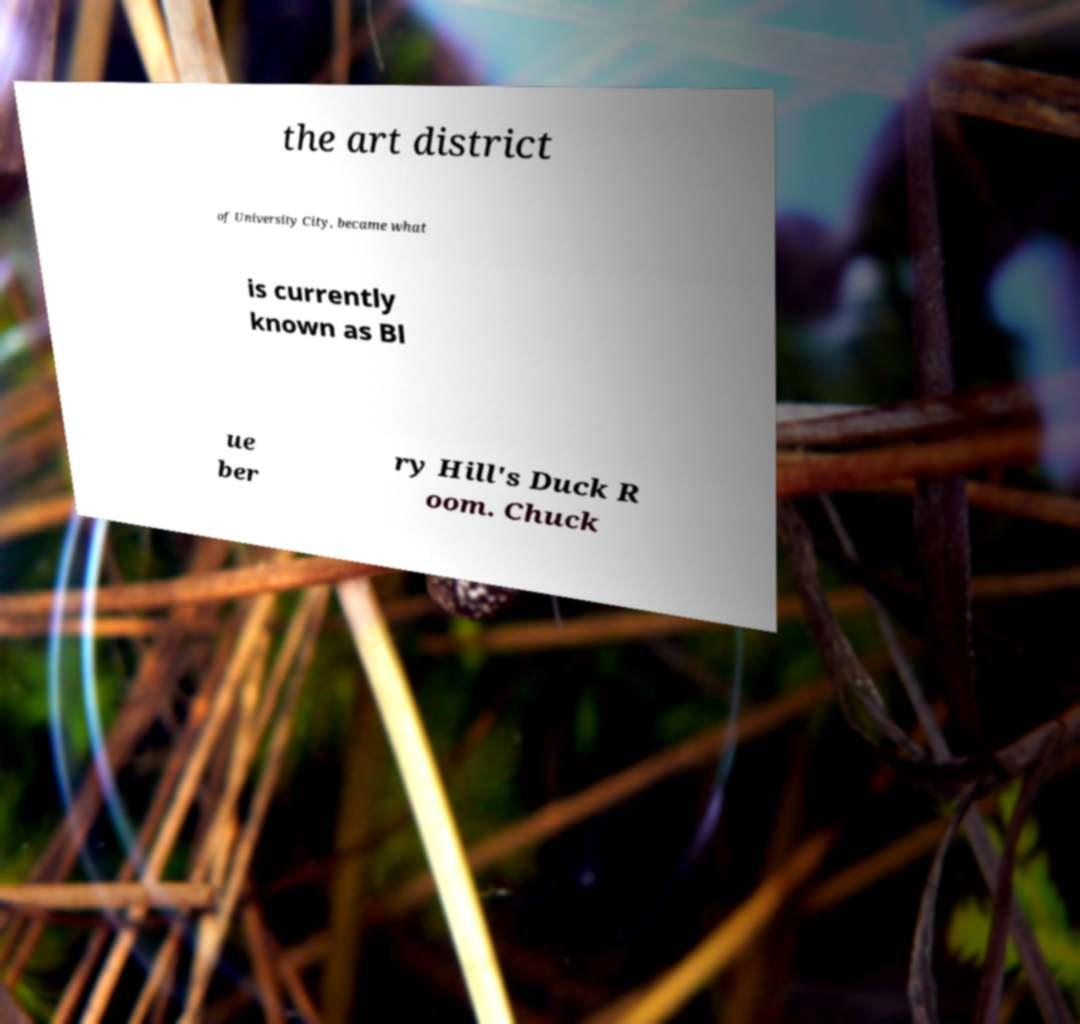Could you assist in decoding the text presented in this image and type it out clearly? the art district of University City, became what is currently known as Bl ue ber ry Hill's Duck R oom. Chuck 